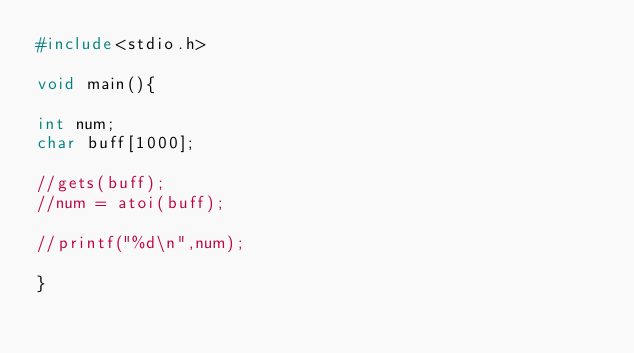<code> <loc_0><loc_0><loc_500><loc_500><_C_>#include<stdio.h>

void main(){

int num;
char buff[1000];

//gets(buff);
//num = atoi(buff);

//printf("%d\n",num);

}</code> 